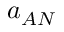<formula> <loc_0><loc_0><loc_500><loc_500>a _ { A N }</formula> 